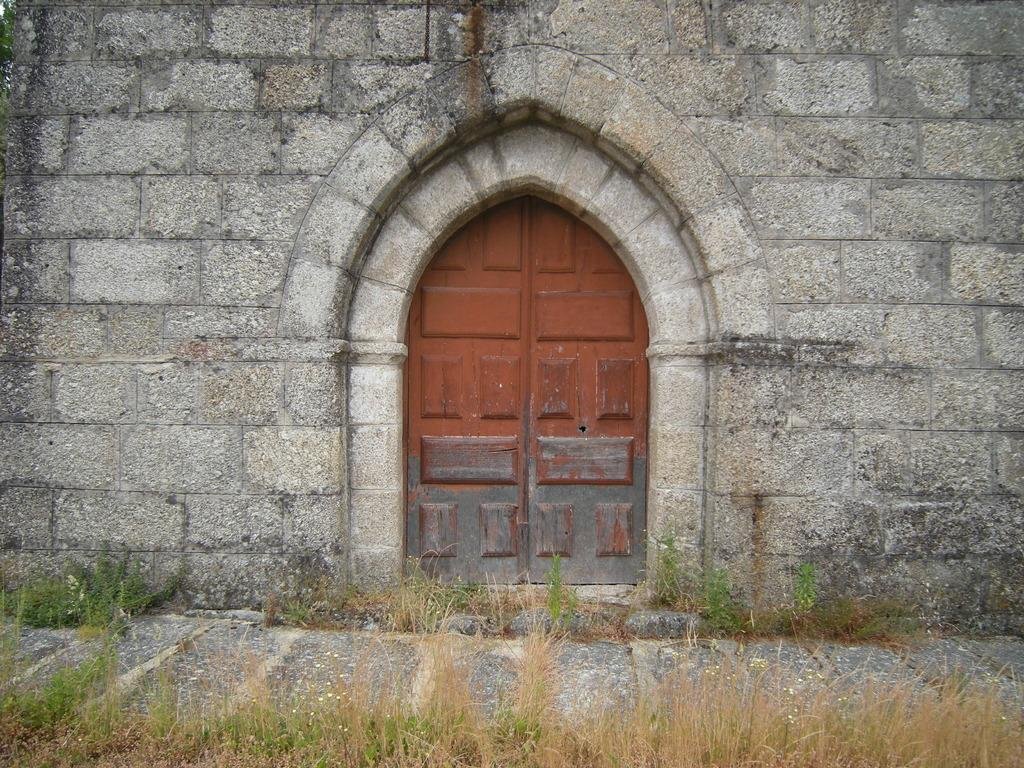What type of structure is visible in the image? There is a wall with a door in the image. What can be seen below the wall in the image? The ground is visible in the image. What type of vegetation is present in the image? There is grass in the image. What type of paper is the doctor holding in the image? There is no doctor or paper present in the image. 